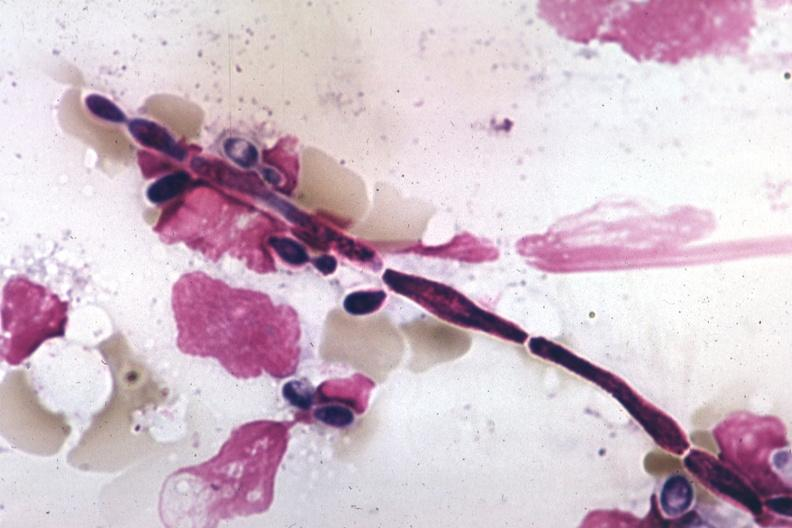does vasculature show pseudohyphal forms?
Answer the question using a single word or phrase. No 